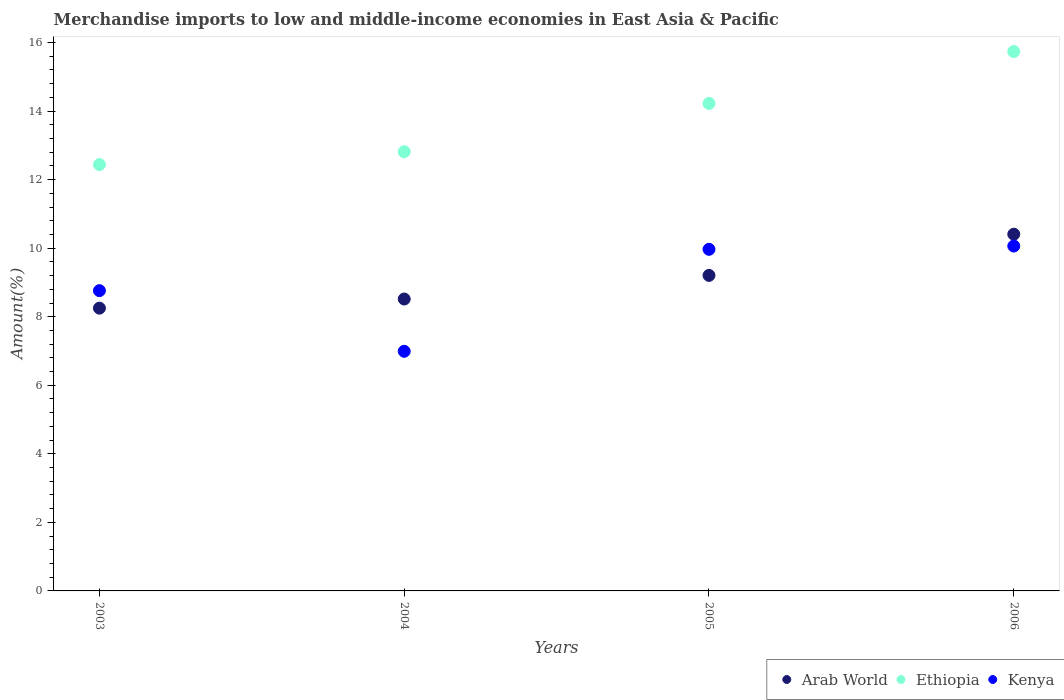How many different coloured dotlines are there?
Your response must be concise. 3. What is the percentage of amount earned from merchandise imports in Kenya in 2005?
Ensure brevity in your answer.  9.97. Across all years, what is the maximum percentage of amount earned from merchandise imports in Ethiopia?
Your response must be concise. 15.74. Across all years, what is the minimum percentage of amount earned from merchandise imports in Arab World?
Give a very brief answer. 8.25. In which year was the percentage of amount earned from merchandise imports in Kenya minimum?
Your answer should be very brief. 2004. What is the total percentage of amount earned from merchandise imports in Ethiopia in the graph?
Ensure brevity in your answer.  55.22. What is the difference between the percentage of amount earned from merchandise imports in Arab World in 2003 and that in 2004?
Keep it short and to the point. -0.27. What is the difference between the percentage of amount earned from merchandise imports in Arab World in 2006 and the percentage of amount earned from merchandise imports in Kenya in 2005?
Offer a terse response. 0.44. What is the average percentage of amount earned from merchandise imports in Kenya per year?
Your answer should be very brief. 8.95. In the year 2006, what is the difference between the percentage of amount earned from merchandise imports in Arab World and percentage of amount earned from merchandise imports in Ethiopia?
Ensure brevity in your answer.  -5.33. What is the ratio of the percentage of amount earned from merchandise imports in Ethiopia in 2004 to that in 2005?
Your answer should be very brief. 0.9. What is the difference between the highest and the second highest percentage of amount earned from merchandise imports in Kenya?
Give a very brief answer. 0.1. What is the difference between the highest and the lowest percentage of amount earned from merchandise imports in Kenya?
Offer a very short reply. 3.07. In how many years, is the percentage of amount earned from merchandise imports in Kenya greater than the average percentage of amount earned from merchandise imports in Kenya taken over all years?
Offer a terse response. 2. Is the sum of the percentage of amount earned from merchandise imports in Kenya in 2003 and 2004 greater than the maximum percentage of amount earned from merchandise imports in Ethiopia across all years?
Offer a very short reply. Yes. Does the percentage of amount earned from merchandise imports in Ethiopia monotonically increase over the years?
Give a very brief answer. Yes. Is the percentage of amount earned from merchandise imports in Kenya strictly greater than the percentage of amount earned from merchandise imports in Ethiopia over the years?
Provide a succinct answer. No. Is the percentage of amount earned from merchandise imports in Ethiopia strictly less than the percentage of amount earned from merchandise imports in Kenya over the years?
Provide a succinct answer. No. How many dotlines are there?
Your answer should be compact. 3. What is the difference between two consecutive major ticks on the Y-axis?
Provide a short and direct response. 2. Does the graph contain grids?
Your answer should be compact. No. Where does the legend appear in the graph?
Offer a terse response. Bottom right. What is the title of the graph?
Make the answer very short. Merchandise imports to low and middle-income economies in East Asia & Pacific. What is the label or title of the X-axis?
Provide a succinct answer. Years. What is the label or title of the Y-axis?
Offer a very short reply. Amount(%). What is the Amount(%) in Arab World in 2003?
Provide a succinct answer. 8.25. What is the Amount(%) of Ethiopia in 2003?
Provide a succinct answer. 12.44. What is the Amount(%) in Kenya in 2003?
Offer a terse response. 8.76. What is the Amount(%) in Arab World in 2004?
Offer a very short reply. 8.52. What is the Amount(%) of Ethiopia in 2004?
Provide a succinct answer. 12.82. What is the Amount(%) of Kenya in 2004?
Provide a succinct answer. 6.99. What is the Amount(%) in Arab World in 2005?
Keep it short and to the point. 9.21. What is the Amount(%) of Ethiopia in 2005?
Your answer should be compact. 14.22. What is the Amount(%) in Kenya in 2005?
Your answer should be very brief. 9.97. What is the Amount(%) of Arab World in 2006?
Make the answer very short. 10.41. What is the Amount(%) of Ethiopia in 2006?
Give a very brief answer. 15.74. What is the Amount(%) in Kenya in 2006?
Your response must be concise. 10.06. Across all years, what is the maximum Amount(%) of Arab World?
Offer a very short reply. 10.41. Across all years, what is the maximum Amount(%) in Ethiopia?
Ensure brevity in your answer.  15.74. Across all years, what is the maximum Amount(%) in Kenya?
Your answer should be very brief. 10.06. Across all years, what is the minimum Amount(%) of Arab World?
Your answer should be compact. 8.25. Across all years, what is the minimum Amount(%) of Ethiopia?
Give a very brief answer. 12.44. Across all years, what is the minimum Amount(%) in Kenya?
Keep it short and to the point. 6.99. What is the total Amount(%) in Arab World in the graph?
Ensure brevity in your answer.  36.38. What is the total Amount(%) in Ethiopia in the graph?
Your answer should be very brief. 55.22. What is the total Amount(%) in Kenya in the graph?
Your response must be concise. 35.78. What is the difference between the Amount(%) of Arab World in 2003 and that in 2004?
Make the answer very short. -0.27. What is the difference between the Amount(%) in Ethiopia in 2003 and that in 2004?
Offer a terse response. -0.38. What is the difference between the Amount(%) in Kenya in 2003 and that in 2004?
Offer a terse response. 1.77. What is the difference between the Amount(%) of Arab World in 2003 and that in 2005?
Provide a succinct answer. -0.96. What is the difference between the Amount(%) of Ethiopia in 2003 and that in 2005?
Ensure brevity in your answer.  -1.78. What is the difference between the Amount(%) of Kenya in 2003 and that in 2005?
Give a very brief answer. -1.21. What is the difference between the Amount(%) in Arab World in 2003 and that in 2006?
Keep it short and to the point. -2.16. What is the difference between the Amount(%) of Ethiopia in 2003 and that in 2006?
Make the answer very short. -3.3. What is the difference between the Amount(%) in Kenya in 2003 and that in 2006?
Your response must be concise. -1.3. What is the difference between the Amount(%) in Arab World in 2004 and that in 2005?
Ensure brevity in your answer.  -0.69. What is the difference between the Amount(%) of Ethiopia in 2004 and that in 2005?
Your answer should be compact. -1.41. What is the difference between the Amount(%) of Kenya in 2004 and that in 2005?
Offer a very short reply. -2.98. What is the difference between the Amount(%) in Arab World in 2004 and that in 2006?
Your answer should be very brief. -1.89. What is the difference between the Amount(%) of Ethiopia in 2004 and that in 2006?
Give a very brief answer. -2.92. What is the difference between the Amount(%) of Kenya in 2004 and that in 2006?
Your response must be concise. -3.07. What is the difference between the Amount(%) in Arab World in 2005 and that in 2006?
Your answer should be compact. -1.2. What is the difference between the Amount(%) of Ethiopia in 2005 and that in 2006?
Provide a short and direct response. -1.51. What is the difference between the Amount(%) of Kenya in 2005 and that in 2006?
Offer a terse response. -0.1. What is the difference between the Amount(%) in Arab World in 2003 and the Amount(%) in Ethiopia in 2004?
Give a very brief answer. -4.56. What is the difference between the Amount(%) of Arab World in 2003 and the Amount(%) of Kenya in 2004?
Offer a very short reply. 1.26. What is the difference between the Amount(%) in Ethiopia in 2003 and the Amount(%) in Kenya in 2004?
Give a very brief answer. 5.45. What is the difference between the Amount(%) of Arab World in 2003 and the Amount(%) of Ethiopia in 2005?
Offer a very short reply. -5.97. What is the difference between the Amount(%) in Arab World in 2003 and the Amount(%) in Kenya in 2005?
Give a very brief answer. -1.72. What is the difference between the Amount(%) of Ethiopia in 2003 and the Amount(%) of Kenya in 2005?
Provide a succinct answer. 2.47. What is the difference between the Amount(%) of Arab World in 2003 and the Amount(%) of Ethiopia in 2006?
Your response must be concise. -7.49. What is the difference between the Amount(%) in Arab World in 2003 and the Amount(%) in Kenya in 2006?
Keep it short and to the point. -1.81. What is the difference between the Amount(%) of Ethiopia in 2003 and the Amount(%) of Kenya in 2006?
Keep it short and to the point. 2.38. What is the difference between the Amount(%) of Arab World in 2004 and the Amount(%) of Ethiopia in 2005?
Provide a short and direct response. -5.71. What is the difference between the Amount(%) in Arab World in 2004 and the Amount(%) in Kenya in 2005?
Offer a terse response. -1.45. What is the difference between the Amount(%) of Ethiopia in 2004 and the Amount(%) of Kenya in 2005?
Ensure brevity in your answer.  2.85. What is the difference between the Amount(%) of Arab World in 2004 and the Amount(%) of Ethiopia in 2006?
Your answer should be compact. -7.22. What is the difference between the Amount(%) in Arab World in 2004 and the Amount(%) in Kenya in 2006?
Keep it short and to the point. -1.55. What is the difference between the Amount(%) of Ethiopia in 2004 and the Amount(%) of Kenya in 2006?
Give a very brief answer. 2.75. What is the difference between the Amount(%) in Arab World in 2005 and the Amount(%) in Ethiopia in 2006?
Give a very brief answer. -6.53. What is the difference between the Amount(%) in Arab World in 2005 and the Amount(%) in Kenya in 2006?
Offer a very short reply. -0.86. What is the difference between the Amount(%) of Ethiopia in 2005 and the Amount(%) of Kenya in 2006?
Make the answer very short. 4.16. What is the average Amount(%) of Arab World per year?
Keep it short and to the point. 9.1. What is the average Amount(%) of Ethiopia per year?
Ensure brevity in your answer.  13.8. What is the average Amount(%) in Kenya per year?
Your answer should be compact. 8.95. In the year 2003, what is the difference between the Amount(%) in Arab World and Amount(%) in Ethiopia?
Make the answer very short. -4.19. In the year 2003, what is the difference between the Amount(%) in Arab World and Amount(%) in Kenya?
Give a very brief answer. -0.51. In the year 2003, what is the difference between the Amount(%) in Ethiopia and Amount(%) in Kenya?
Keep it short and to the point. 3.68. In the year 2004, what is the difference between the Amount(%) of Arab World and Amount(%) of Ethiopia?
Your answer should be very brief. -4.3. In the year 2004, what is the difference between the Amount(%) in Arab World and Amount(%) in Kenya?
Provide a succinct answer. 1.53. In the year 2004, what is the difference between the Amount(%) in Ethiopia and Amount(%) in Kenya?
Offer a terse response. 5.82. In the year 2005, what is the difference between the Amount(%) in Arab World and Amount(%) in Ethiopia?
Offer a very short reply. -5.02. In the year 2005, what is the difference between the Amount(%) in Arab World and Amount(%) in Kenya?
Provide a short and direct response. -0.76. In the year 2005, what is the difference between the Amount(%) of Ethiopia and Amount(%) of Kenya?
Offer a terse response. 4.26. In the year 2006, what is the difference between the Amount(%) of Arab World and Amount(%) of Ethiopia?
Provide a succinct answer. -5.33. In the year 2006, what is the difference between the Amount(%) in Arab World and Amount(%) in Kenya?
Your answer should be very brief. 0.35. In the year 2006, what is the difference between the Amount(%) in Ethiopia and Amount(%) in Kenya?
Your answer should be very brief. 5.67. What is the ratio of the Amount(%) in Arab World in 2003 to that in 2004?
Your response must be concise. 0.97. What is the ratio of the Amount(%) in Ethiopia in 2003 to that in 2004?
Offer a very short reply. 0.97. What is the ratio of the Amount(%) of Kenya in 2003 to that in 2004?
Keep it short and to the point. 1.25. What is the ratio of the Amount(%) in Arab World in 2003 to that in 2005?
Provide a succinct answer. 0.9. What is the ratio of the Amount(%) of Ethiopia in 2003 to that in 2005?
Provide a short and direct response. 0.87. What is the ratio of the Amount(%) in Kenya in 2003 to that in 2005?
Your answer should be very brief. 0.88. What is the ratio of the Amount(%) in Arab World in 2003 to that in 2006?
Offer a terse response. 0.79. What is the ratio of the Amount(%) in Ethiopia in 2003 to that in 2006?
Offer a terse response. 0.79. What is the ratio of the Amount(%) in Kenya in 2003 to that in 2006?
Your answer should be very brief. 0.87. What is the ratio of the Amount(%) of Arab World in 2004 to that in 2005?
Keep it short and to the point. 0.93. What is the ratio of the Amount(%) of Ethiopia in 2004 to that in 2005?
Your answer should be compact. 0.9. What is the ratio of the Amount(%) of Kenya in 2004 to that in 2005?
Offer a very short reply. 0.7. What is the ratio of the Amount(%) in Arab World in 2004 to that in 2006?
Your answer should be compact. 0.82. What is the ratio of the Amount(%) of Ethiopia in 2004 to that in 2006?
Make the answer very short. 0.81. What is the ratio of the Amount(%) of Kenya in 2004 to that in 2006?
Provide a short and direct response. 0.69. What is the ratio of the Amount(%) in Arab World in 2005 to that in 2006?
Offer a very short reply. 0.88. What is the ratio of the Amount(%) of Ethiopia in 2005 to that in 2006?
Your response must be concise. 0.9. What is the difference between the highest and the second highest Amount(%) in Arab World?
Your answer should be compact. 1.2. What is the difference between the highest and the second highest Amount(%) in Ethiopia?
Give a very brief answer. 1.51. What is the difference between the highest and the second highest Amount(%) in Kenya?
Ensure brevity in your answer.  0.1. What is the difference between the highest and the lowest Amount(%) of Arab World?
Keep it short and to the point. 2.16. What is the difference between the highest and the lowest Amount(%) in Ethiopia?
Offer a terse response. 3.3. What is the difference between the highest and the lowest Amount(%) in Kenya?
Keep it short and to the point. 3.07. 